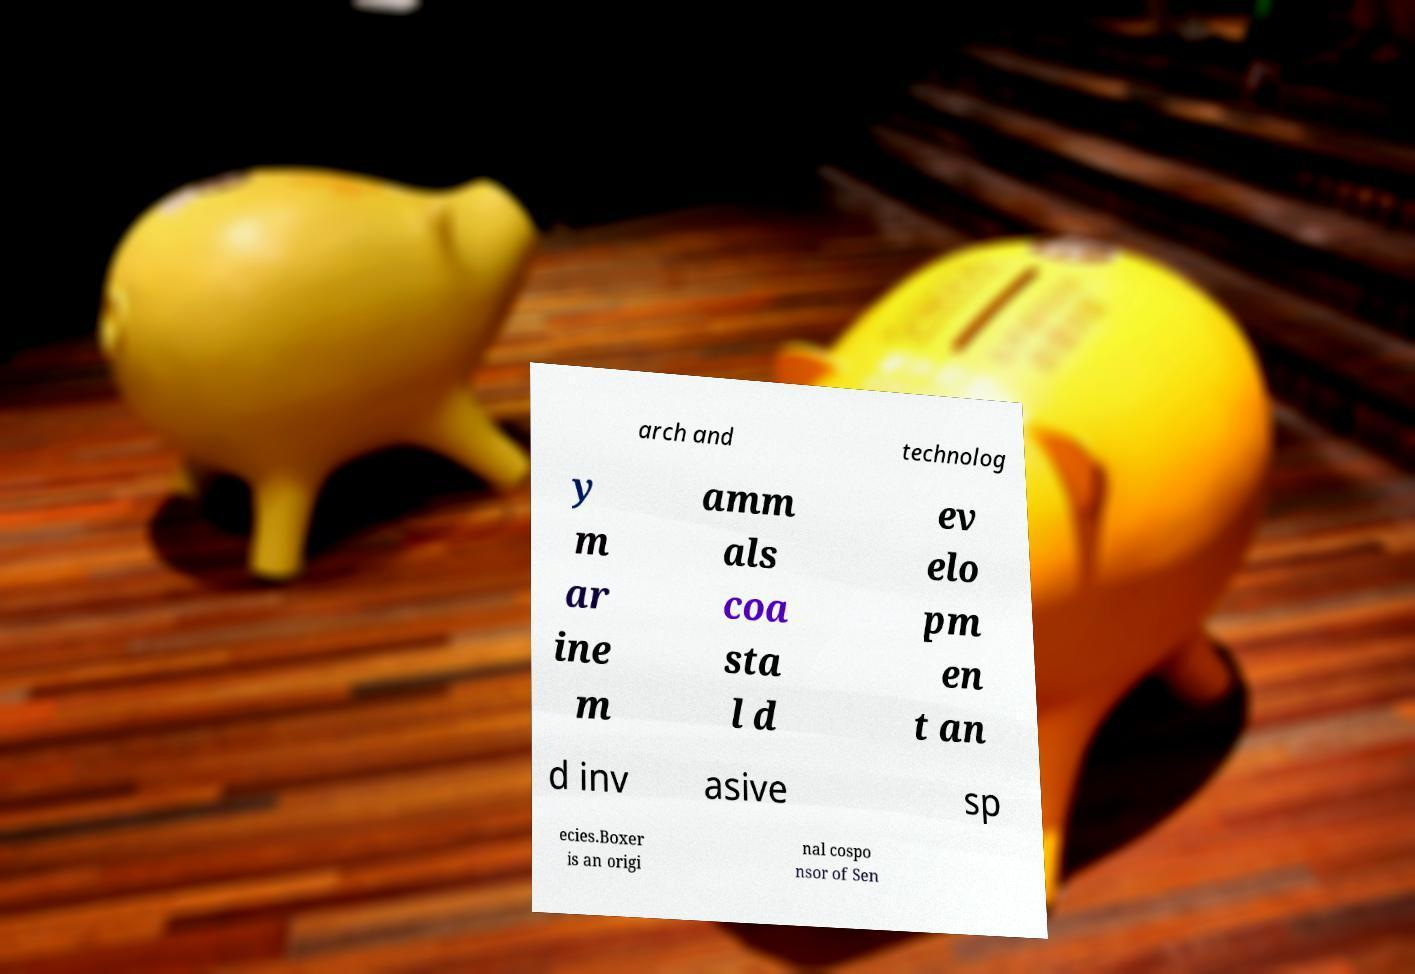I need the written content from this picture converted into text. Can you do that? arch and technolog y m ar ine m amm als coa sta l d ev elo pm en t an d inv asive sp ecies.Boxer is an origi nal cospo nsor of Sen 